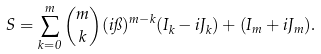Convert formula to latex. <formula><loc_0><loc_0><loc_500><loc_500>S = \sum _ { k = 0 } ^ { m } \binom { m } { k } ( i \pi ) ^ { m - k } ( I _ { k } - i J _ { k } ) + ( I _ { m } + i J _ { m } ) .</formula> 